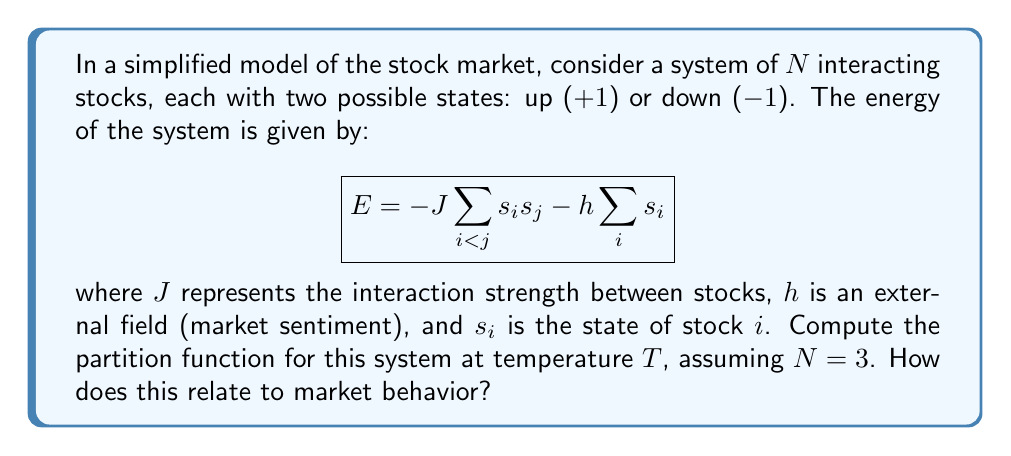Can you answer this question? To compute the partition function, we follow these steps:

1) The partition function is given by:
   $$Z = \sum_{\text{all states}} e^{-\beta E}$$
   where $\beta = \frac{1}{k_B T}$, and $k_B$ is Boltzmann's constant.

2) For $N=3$ stocks, we have $2^3 = 8$ possible states. Let's enumerate them:
   $(+1,+1,+1)$, $(+1,+1,-1)$, $(+1,-1,+1)$, $(-1,+1,+1)$, $(+1,-1,-1)$, $(-1,+1,-1)$, $(-1,-1,+1)$, $(-1,-1,-1)$

3) Calculate the energy for each state:
   - For $(+1,+1,+1)$: $E = -3J - 3h$
   - For $(+1,+1,-1)$, $(+1,-1,+1)$, $(-1,+1,+1)$: $E = -J - h$
   - For $(+1,-1,-1)$, $(-1,+1,-1)$, $(-1,-1,+1)$: $E = -J + h$
   - For $(-1,-1,-1)$: $E = -3J + 3h$

4) Now, we can write out the partition function:
   $$Z = e^{\beta(3J+3h)} + 3e^{\beta(J+h)} + 3e^{\beta(J-h)} + e^{\beta(3J-3h)}$$

5) This can be simplified to:
   $$Z = e^{3\beta J}(e^{3\beta h} + 3e^{\beta h} + 3e^{-\beta h} + e^{-3\beta h})$$

6) Relation to market behavior:
   - $J > 0$ indicates herding behavior (stocks tend to move together)
   - $h > 0$ represents overall bullish sentiment, $h < 0$ bearish sentiment
   - Higher $T$ (lower $\beta$) indicates more random market behavior
   - The partition function helps calculate probabilities of different market states and average market properties
Answer: $$Z = e^{3\beta J}(e^{3\beta h} + 3e^{\beta h} + 3e^{-\beta h} + e^{-3\beta h})$$ 